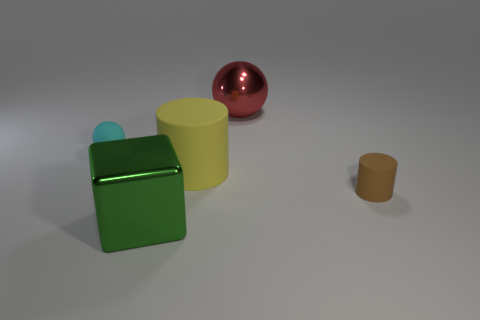Add 5 yellow matte objects. How many objects exist? 10 Subtract all balls. How many objects are left? 3 Subtract 1 brown cylinders. How many objects are left? 4 Subtract all red spheres. Subtract all green cubes. How many spheres are left? 1 Subtract all big matte cylinders. Subtract all cyan matte spheres. How many objects are left? 3 Add 4 tiny brown objects. How many tiny brown objects are left? 5 Add 4 brown cylinders. How many brown cylinders exist? 5 